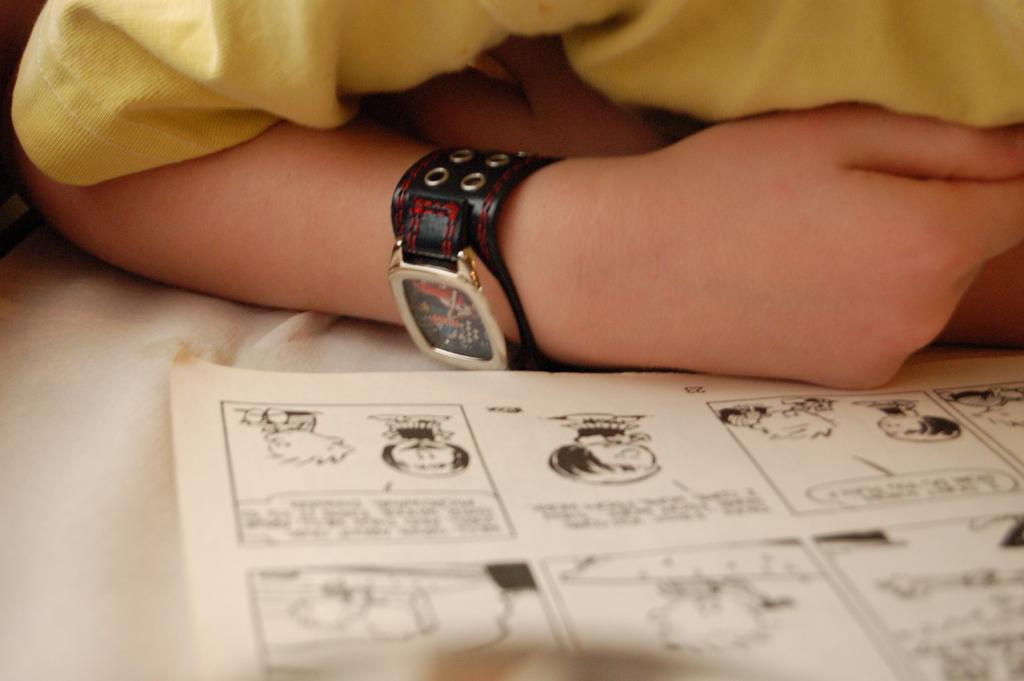Describe this image in one or two sentences. At the bottom of this image, there is a chart, on which there are paintings and texts. Beside this chart, there is a person in yellow color T-shirt, wearing a watch. 